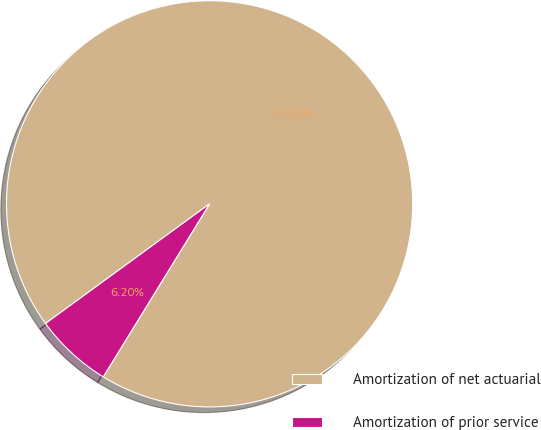Convert chart. <chart><loc_0><loc_0><loc_500><loc_500><pie_chart><fcel>Amortization of net actuarial<fcel>Amortization of prior service<nl><fcel>93.8%<fcel>6.2%<nl></chart> 